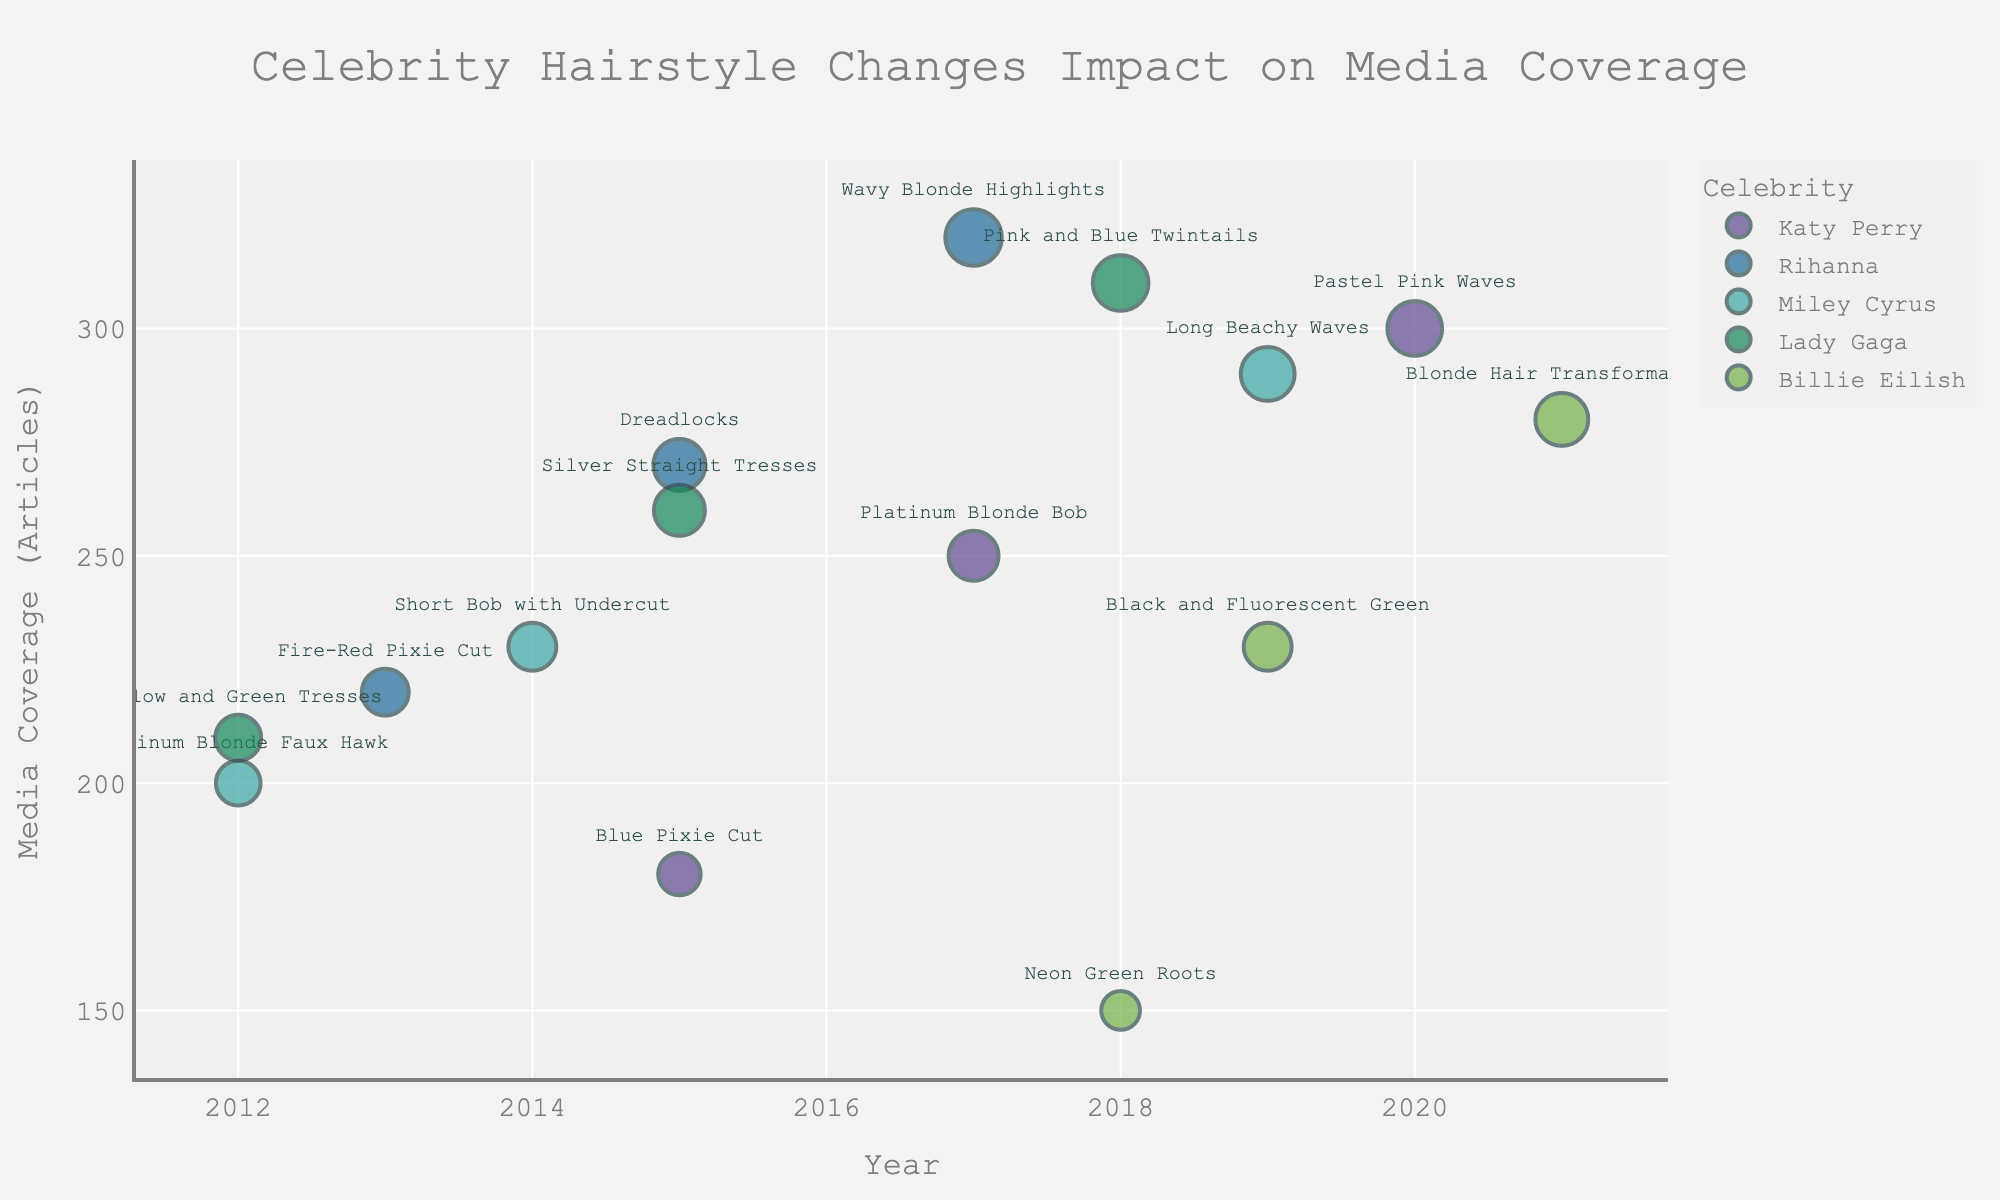What is the title of the scatter plot? The title is usually displayed at the top of the scatter plot. In this case, it mentions the key elements being analyzed.
Answer: Celebrity Hairstyle Changes Impact on Media Coverage Which celebrity had the highest media coverage level in 2020? Look for the year 2020 on the x-axis and identify the corresponding data point with the highest y-value (Media Coverage Level).
Answer: Katy Perry What was the media coverage level for Billie Eilish in 2021? Locate 2021 on the x-axis and find the data point for Billie Eilish. Read the y-axis value for that point.
Answer: 280 Compare the media coverage levels between Katy Perry's Platinum Blonde Bob (2017) and Rihanna's Wavy Blonde Highlights (2017). Which was higher? Identify both data points in 2017 and compare their y-axis values.
Answer: Rihanna’s Wavy Blonde Highlights How many total hairstyle changes did Miley Cyrus show in the dataset? Count all distinct points associated with Miley Cyrus in the plot.
Answer: 3 Which celebrity had the most dramatic increase in media coverage between two consecutive hairstyle changes? Compare the media coverage values for consecutive hairstyle changes of each celebrity and find the largest increase.
Answer: Rihanna (2013 - 2015) What was the total media coverage level for Lady Gaga across all the years? Sum the media coverage levels of Lady Gaga's data points.
Answer: 780 How did the media coverage trend over time for Katy Perry? Observe the data points for Katy Perry from left to right (increasing years) and note the y-values (media coverage).
Answer: Increasing Which year featured the most hairstyle changes among all celebrities? Count the number of data points per year and identify the year with the highest count.
Answer: 2015 What is the median media coverage level across all data points in the plot? List all media coverage levels, sort them, and find the middle value in the sorted list.
Answer: 250 